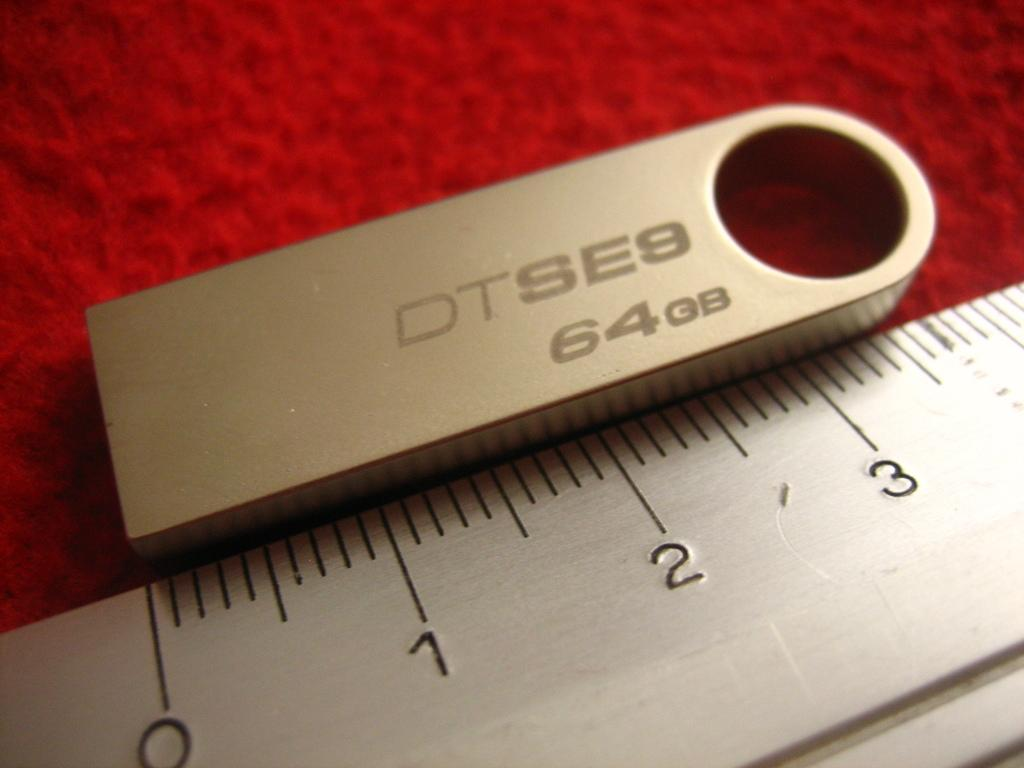Provide a one-sentence caption for the provided image. A very small 64 GB memory card that is just over 3" long. 